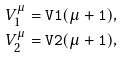<formula> <loc_0><loc_0><loc_500><loc_500>V _ { 1 } ^ { \mu } & = { \tt V 1 ( \mu + 1 ) } , \\ V _ { 2 } ^ { \mu } & = { \tt V 2 ( \mu + 1 ) } ,</formula> 